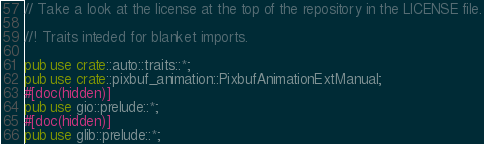Convert code to text. <code><loc_0><loc_0><loc_500><loc_500><_Rust_>// Take a look at the license at the top of the repository in the LICENSE file.

//! Traits inteded for blanket imports.

pub use crate::auto::traits::*;
pub use crate::pixbuf_animation::PixbufAnimationExtManual;
#[doc(hidden)]
pub use gio::prelude::*;
#[doc(hidden)]
pub use glib::prelude::*;
</code> 